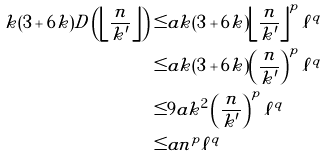Convert formula to latex. <formula><loc_0><loc_0><loc_500><loc_500>k ( 3 + 6 k ) D \left ( \left \lfloor \frac { n } { k ^ { \prime } } \right \rfloor \right ) \leq & a k ( 3 + 6 k ) \left \lfloor \frac { n } { k ^ { \prime } } \right \rfloor ^ { p } \ell ^ { q } \\ \leq & a k ( 3 + 6 k ) \left ( \frac { n } { k ^ { \prime } } \right ) ^ { p } \ell ^ { q } \\ \leq & 9 a k ^ { 2 } \left ( \frac { n } { k ^ { \prime } } \right ) ^ { p } \ell ^ { q } \\ \leq & a n ^ { p } \ell ^ { q }</formula> 